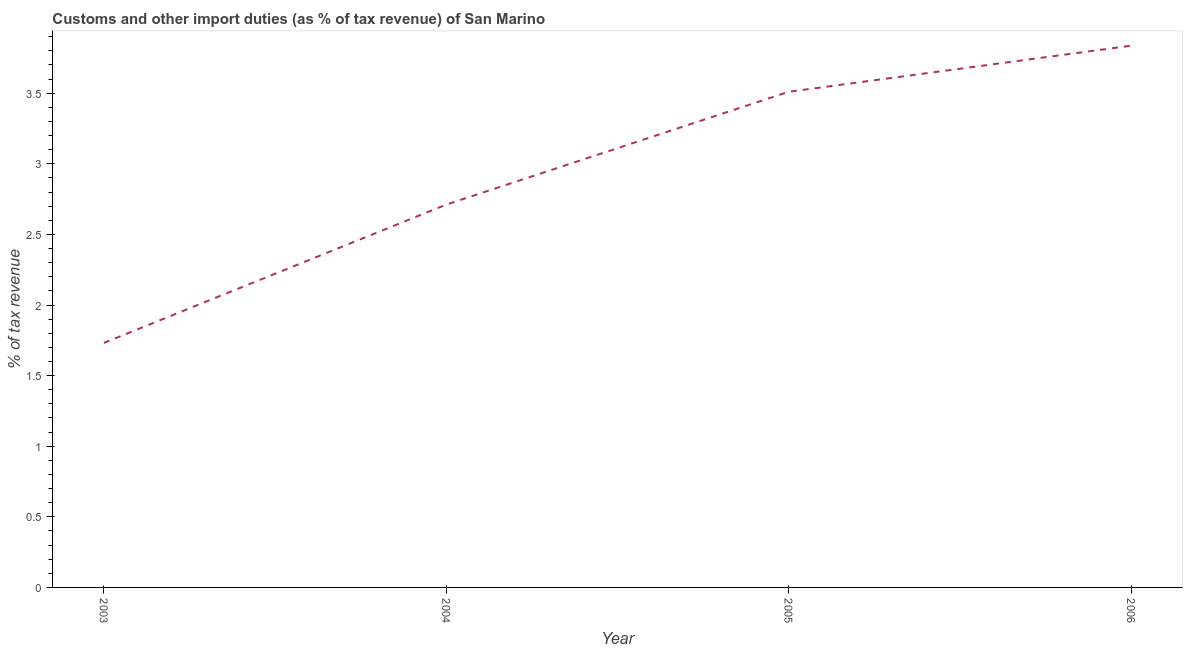What is the customs and other import duties in 2003?
Give a very brief answer. 1.73. Across all years, what is the maximum customs and other import duties?
Ensure brevity in your answer.  3.84. Across all years, what is the minimum customs and other import duties?
Offer a terse response. 1.73. In which year was the customs and other import duties maximum?
Keep it short and to the point. 2006. In which year was the customs and other import duties minimum?
Keep it short and to the point. 2003. What is the sum of the customs and other import duties?
Offer a terse response. 11.79. What is the difference between the customs and other import duties in 2003 and 2004?
Keep it short and to the point. -0.98. What is the average customs and other import duties per year?
Ensure brevity in your answer.  2.95. What is the median customs and other import duties?
Ensure brevity in your answer.  3.11. In how many years, is the customs and other import duties greater than 0.1 %?
Your answer should be compact. 4. Do a majority of the years between 2003 and 2005 (inclusive) have customs and other import duties greater than 1.4 %?
Ensure brevity in your answer.  Yes. What is the ratio of the customs and other import duties in 2003 to that in 2006?
Ensure brevity in your answer.  0.45. Is the difference between the customs and other import duties in 2003 and 2005 greater than the difference between any two years?
Ensure brevity in your answer.  No. What is the difference between the highest and the second highest customs and other import duties?
Your answer should be compact. 0.33. What is the difference between the highest and the lowest customs and other import duties?
Offer a terse response. 2.11. Does the customs and other import duties monotonically increase over the years?
Your response must be concise. Yes. How many lines are there?
Offer a very short reply. 1. Does the graph contain any zero values?
Offer a very short reply. No. Does the graph contain grids?
Offer a terse response. No. What is the title of the graph?
Your answer should be very brief. Customs and other import duties (as % of tax revenue) of San Marino. What is the label or title of the X-axis?
Give a very brief answer. Year. What is the label or title of the Y-axis?
Provide a short and direct response. % of tax revenue. What is the % of tax revenue of 2003?
Your answer should be compact. 1.73. What is the % of tax revenue of 2004?
Provide a short and direct response. 2.71. What is the % of tax revenue of 2005?
Your answer should be compact. 3.51. What is the % of tax revenue in 2006?
Provide a short and direct response. 3.84. What is the difference between the % of tax revenue in 2003 and 2004?
Give a very brief answer. -0.98. What is the difference between the % of tax revenue in 2003 and 2005?
Keep it short and to the point. -1.78. What is the difference between the % of tax revenue in 2003 and 2006?
Your answer should be very brief. -2.11. What is the difference between the % of tax revenue in 2004 and 2005?
Your answer should be compact. -0.8. What is the difference between the % of tax revenue in 2004 and 2006?
Your response must be concise. -1.13. What is the difference between the % of tax revenue in 2005 and 2006?
Make the answer very short. -0.33. What is the ratio of the % of tax revenue in 2003 to that in 2004?
Ensure brevity in your answer.  0.64. What is the ratio of the % of tax revenue in 2003 to that in 2005?
Provide a succinct answer. 0.49. What is the ratio of the % of tax revenue in 2003 to that in 2006?
Give a very brief answer. 0.45. What is the ratio of the % of tax revenue in 2004 to that in 2005?
Your answer should be compact. 0.77. What is the ratio of the % of tax revenue in 2004 to that in 2006?
Give a very brief answer. 0.71. What is the ratio of the % of tax revenue in 2005 to that in 2006?
Your response must be concise. 0.92. 